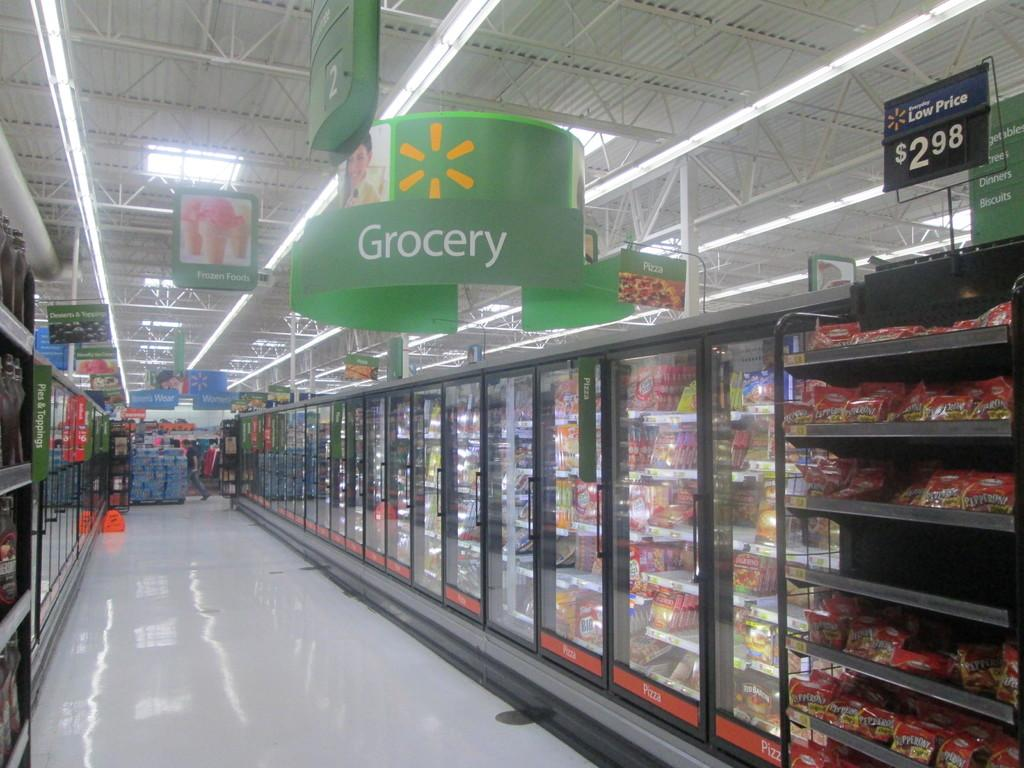<image>
Write a terse but informative summary of the picture. a freezer aisle with a grocery sign above the aisle 